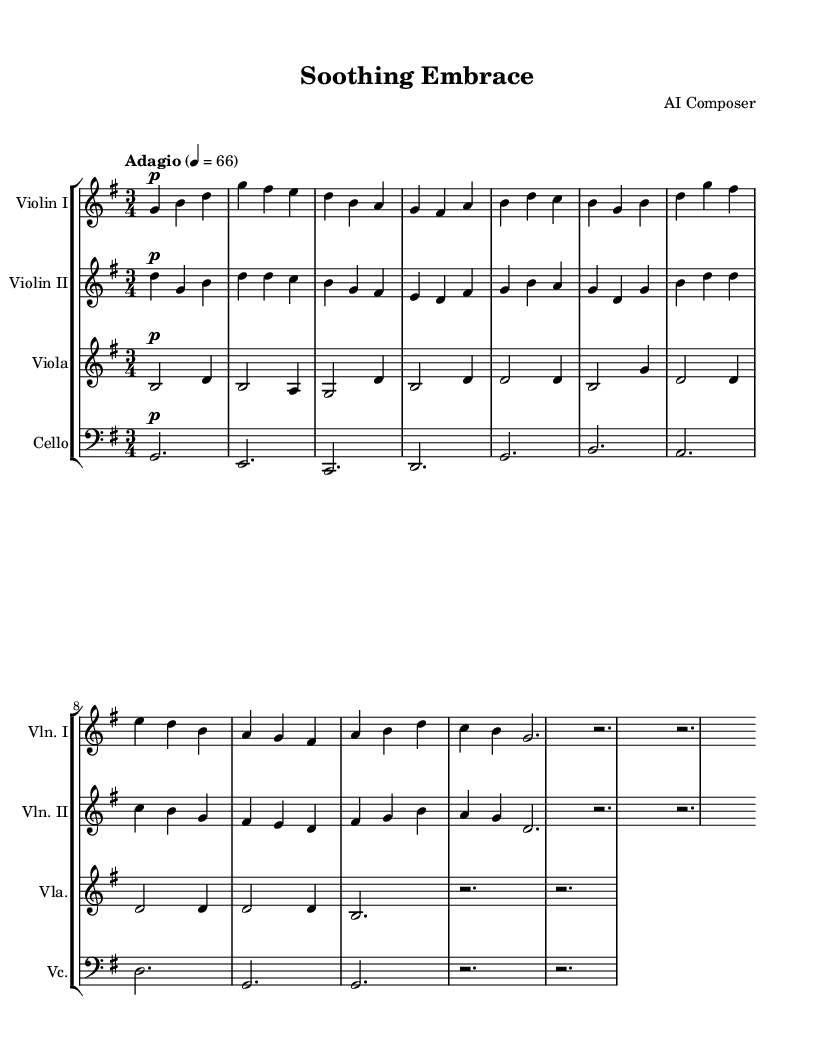What is the key signature of this music? The key signature is G major, which has one sharp (F#). This can be identified by looking at the key signature indicated at the beginning of the staff, which is the first symbol after the treble clef.
Answer: G major What is the time signature of the piece? The time signature is 3/4, which can be identified by the notation that appears after the key signature. This signifies that there are three beats in each measure and that a quarter note receives one beat.
Answer: 3/4 What is the tempo marking of this composition? The tempo marking is "Adagio," indicating a slow pace. This marking is typically placed above the staff and is associated with the beats-per-minute listed as 4 = 66, meaning the quarter note should be played at a speed of sixty-six beats per minute.
Answer: Adagio How many measures are in the piece? There are six measures in the provided part of the music. This can be ascertained by counting the groups of notes separated by vertical bar lines in the staff notation. Each group is one measure.
Answer: 6 What is the dynamic marking for Violin I? The dynamic marking for Violin I is piano (p), which means to play softly. This is indicated at the start of Violin I's part to ensure the musician plays with a gentle touch.
Answer: piano Which instrument plays the lowest pitch in the quartet? The cello plays the lowest pitch in the quartet. This can be observed as the cello part is written in bass clef, which is typically used for lower-pitched instruments, and its range is lower than the other string instruments in the ensemble.
Answer: cello What is the ornamental feature at the end of the piece? The ornamental feature at the end of the piece is a fermata, which indicates to hold the last note for longer than its usual duration. This can be identified by the symbol, which looks like a dot over a curved line.
Answer: fermata 